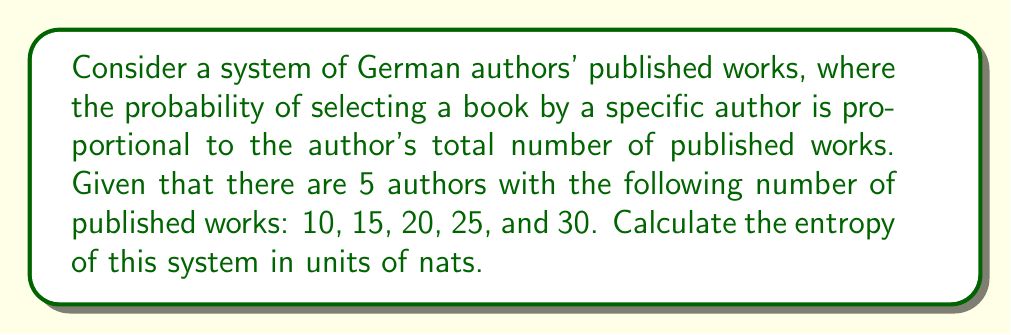Teach me how to tackle this problem. To calculate the entropy of this system, we'll follow these steps:

1. Calculate the total number of published works:
   $N_{total} = 10 + 15 + 20 + 25 + 30 = 100$

2. Calculate the probability of selecting a book from each author:
   $p_1 = \frac{10}{100} = 0.1$
   $p_2 = \frac{15}{100} = 0.15$
   $p_3 = \frac{20}{100} = 0.2$
   $p_4 = \frac{25}{100} = 0.25$
   $p_5 = \frac{30}{100} = 0.3$

3. Use the entropy formula:
   $S = -k_B \sum_{i=1}^{5} p_i \ln(p_i)$
   
   Where $k_B$ is Boltzmann's constant, but since we're using nats, we can set $k_B = 1$.

4. Calculate each term:
   $-0.1 \ln(0.1) \approx 0.2303$
   $-0.15 \ln(0.15) \approx 0.2860$
   $-0.2 \ln(0.2) \approx 0.3219$
   $-0.25 \ln(0.25) \approx 0.3466$
   $-0.3 \ln(0.3) \approx 0.3611$

5. Sum all terms:
   $S = 0.2303 + 0.2860 + 0.3219 + 0.3466 + 0.3611 = 1.5459$ nats
Answer: 1.5459 nats 